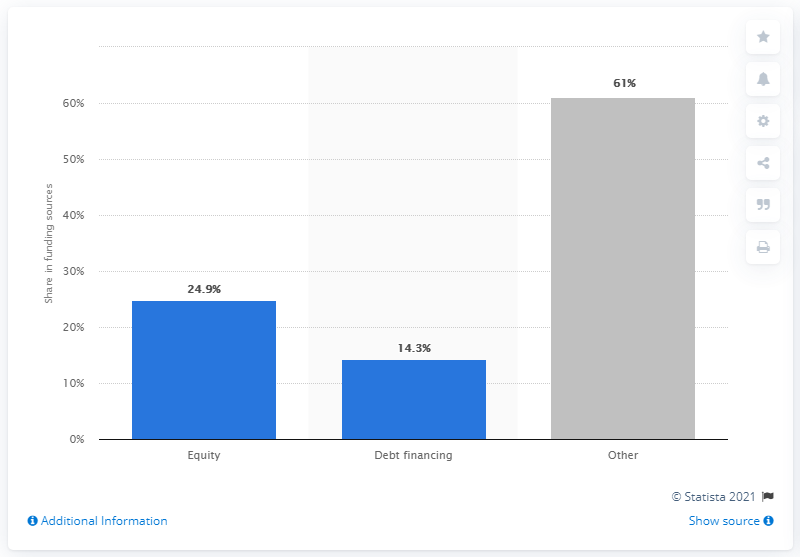List a handful of essential elements in this visual. In 2015, micro-lending institutions in Romania received approximately 61% of their funding from private sources. 